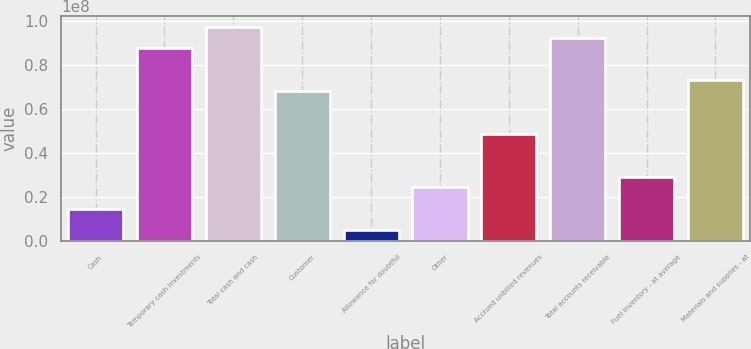Convert chart to OTSL. <chart><loc_0><loc_0><loc_500><loc_500><bar_chart><fcel>Cash<fcel>Temporary cash investments<fcel>Total cash and cash<fcel>Customer<fcel>Allowance for doubtful<fcel>Other<fcel>Accrued unbilled revenues<fcel>Total accounts receivable<fcel>Fuel inventory - at average<fcel>Materials and supplies - at<nl><fcel>1.45922e+07<fcel>8.75519e+07<fcel>9.72799e+07<fcel>6.8096e+07<fcel>4.86418e+06<fcel>2.43201e+07<fcel>4.864e+07<fcel>9.24159e+07<fcel>2.91841e+07<fcel>7.296e+07<nl></chart> 